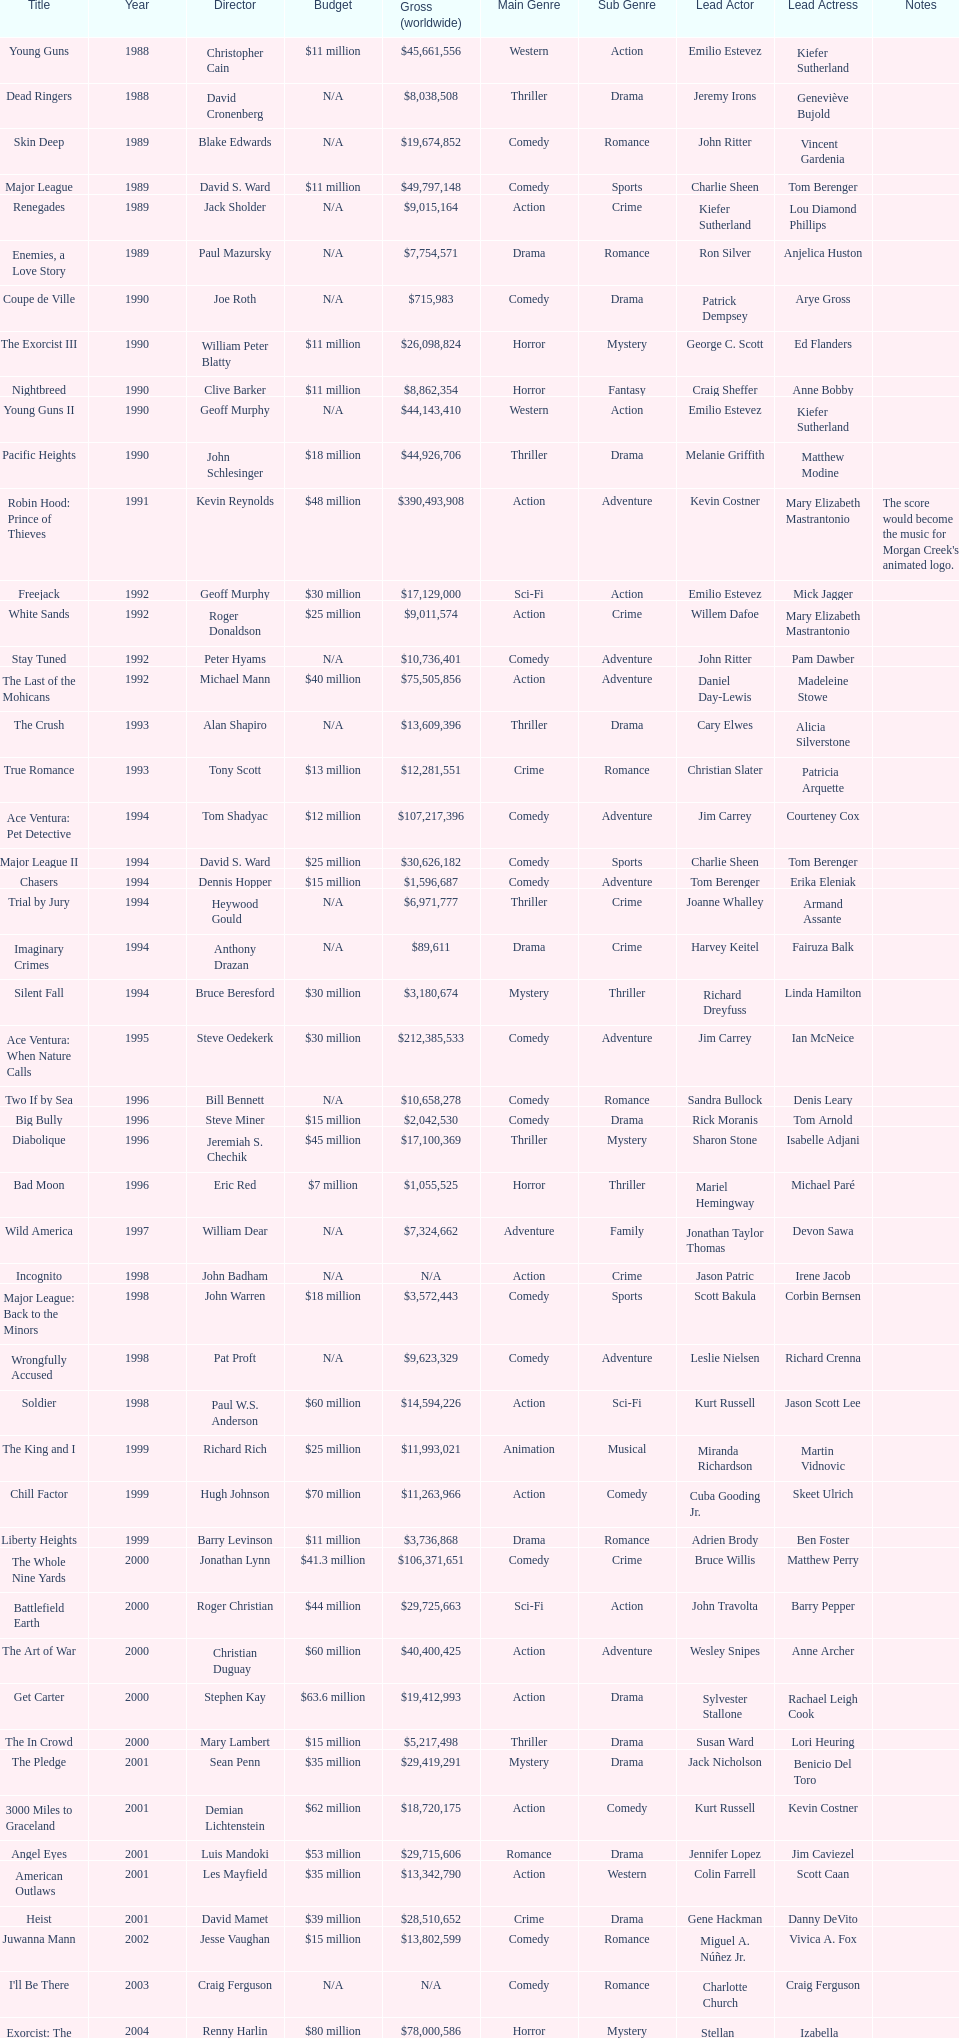After young guns, what was the next movie with the exact same budget? Major League. 